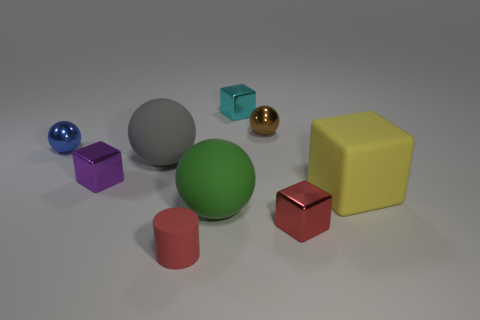There is a cube that is the same color as the tiny cylinder; what is it made of?
Make the answer very short. Metal. Are there any cylinders in front of the small cylinder?
Your answer should be very brief. No. Do the matte thing that is in front of the large green rubber thing and the tiny metallic block that is in front of the purple object have the same color?
Keep it short and to the point. Yes. Are there any tiny purple objects of the same shape as the large yellow thing?
Keep it short and to the point. Yes. How many other objects are there of the same color as the matte cylinder?
Give a very brief answer. 1. What is the color of the small cube to the right of the block that is behind the tiny metal sphere that is in front of the tiny brown sphere?
Offer a very short reply. Red. Are there the same number of metallic objects on the right side of the tiny brown ball and tiny balls?
Offer a very short reply. No. There is a sphere in front of the rubber cube; is it the same size as the big yellow object?
Your response must be concise. Yes. How many small blue blocks are there?
Give a very brief answer. 0. What number of tiny metal objects are both in front of the small cyan metallic cube and behind the tiny blue sphere?
Provide a short and direct response. 1. 